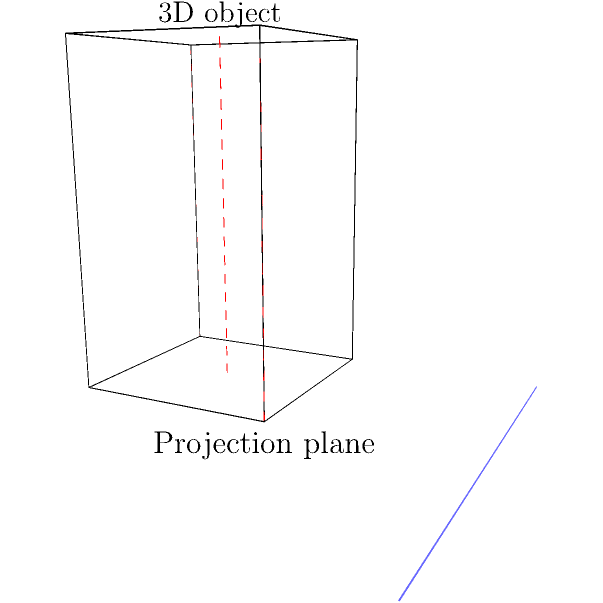In an ARKit application, you need to project a 3D cube onto a 2D plane for display. Given that the cube has a side length of 2 units and its center is located at $(1, 1, 1)$ in the 3D space, what will be the $x$ and $y$ coordinates of the projected center point on the 2D plane if the projection plane is at $z = 0$ and the projection is orthographic? To solve this problem, we need to follow these steps:

1. Understand orthographic projection:
   In orthographic projection, the projection lines are perpendicular to the projection plane.

2. Identify the relevant information:
   - The cube's center is at $(1, 1, 1)$ in 3D space.
   - The projection plane is at $z = 0$.
   - We're using orthographic projection.

3. Determine the projection method:
   In orthographic projection, the $x$ and $y$ coordinates remain unchanged, while the $z$ coordinate is discarded.

4. Calculate the projected coordinates:
   - The $x$ coordinate of the projected point will be the same as the $x$ coordinate of the 3D point: $x = 1$.
   - The $y$ coordinate of the projected point will be the same as the $y$ coordinate of the 3D point: $y = 1$.
   - The $z$ coordinate is discarded in the 2D projection.

5. Express the result:
   The projected center point on the 2D plane will have coordinates $(1, 1)$.

This projection preserves the parallel lines and relative dimensions of the object, which is crucial for accurate AR display.
Answer: $(1, 1)$ 